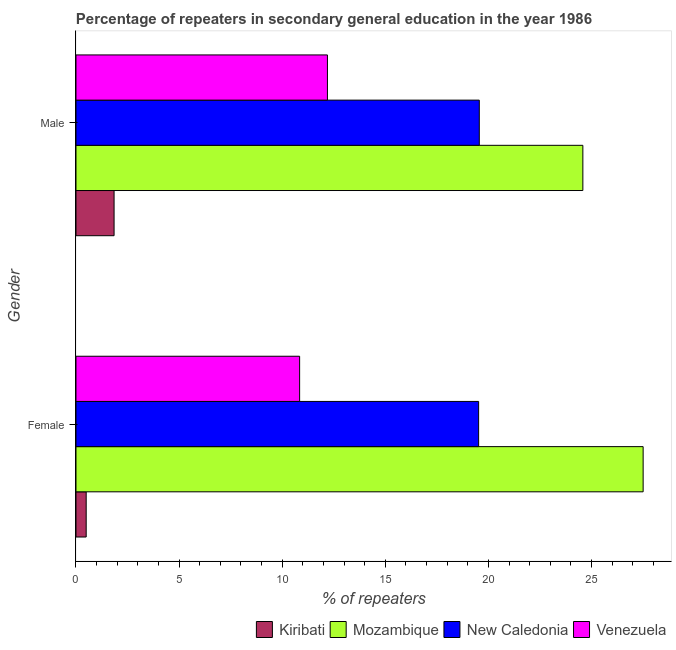How many different coloured bars are there?
Your answer should be compact. 4. Are the number of bars on each tick of the Y-axis equal?
Ensure brevity in your answer.  Yes. How many bars are there on the 1st tick from the top?
Keep it short and to the point. 4. What is the label of the 2nd group of bars from the top?
Your response must be concise. Female. What is the percentage of female repeaters in Kiribati?
Your response must be concise. 0.49. Across all countries, what is the maximum percentage of female repeaters?
Make the answer very short. 27.5. Across all countries, what is the minimum percentage of male repeaters?
Your response must be concise. 1.85. In which country was the percentage of female repeaters maximum?
Keep it short and to the point. Mozambique. In which country was the percentage of female repeaters minimum?
Ensure brevity in your answer.  Kiribati. What is the total percentage of female repeaters in the graph?
Keep it short and to the point. 58.37. What is the difference between the percentage of female repeaters in New Caledonia and that in Venezuela?
Offer a very short reply. 8.68. What is the difference between the percentage of male repeaters in Kiribati and the percentage of female repeaters in Mozambique?
Your answer should be compact. -25.66. What is the average percentage of male repeaters per country?
Your response must be concise. 14.54. What is the difference between the percentage of male repeaters and percentage of female repeaters in New Caledonia?
Give a very brief answer. 0.03. What is the ratio of the percentage of female repeaters in Venezuela to that in New Caledonia?
Provide a short and direct response. 0.56. Is the percentage of male repeaters in New Caledonia less than that in Mozambique?
Offer a terse response. Yes. What does the 4th bar from the top in Male represents?
Make the answer very short. Kiribati. What does the 2nd bar from the bottom in Male represents?
Your answer should be very brief. Mozambique. What is the difference between two consecutive major ticks on the X-axis?
Offer a terse response. 5. Where does the legend appear in the graph?
Ensure brevity in your answer.  Bottom right. How are the legend labels stacked?
Ensure brevity in your answer.  Horizontal. What is the title of the graph?
Offer a very short reply. Percentage of repeaters in secondary general education in the year 1986. What is the label or title of the X-axis?
Provide a succinct answer. % of repeaters. What is the % of repeaters of Kiribati in Female?
Your answer should be very brief. 0.49. What is the % of repeaters in Mozambique in Female?
Provide a succinct answer. 27.5. What is the % of repeaters in New Caledonia in Female?
Make the answer very short. 19.52. What is the % of repeaters in Venezuela in Female?
Provide a succinct answer. 10.84. What is the % of repeaters of Kiribati in Male?
Offer a very short reply. 1.85. What is the % of repeaters of Mozambique in Male?
Offer a very short reply. 24.58. What is the % of repeaters of New Caledonia in Male?
Keep it short and to the point. 19.56. What is the % of repeaters of Venezuela in Male?
Provide a short and direct response. 12.19. Across all Gender, what is the maximum % of repeaters of Kiribati?
Provide a succinct answer. 1.85. Across all Gender, what is the maximum % of repeaters of Mozambique?
Offer a very short reply. 27.5. Across all Gender, what is the maximum % of repeaters in New Caledonia?
Provide a succinct answer. 19.56. Across all Gender, what is the maximum % of repeaters of Venezuela?
Give a very brief answer. 12.19. Across all Gender, what is the minimum % of repeaters in Kiribati?
Your answer should be compact. 0.49. Across all Gender, what is the minimum % of repeaters in Mozambique?
Provide a short and direct response. 24.58. Across all Gender, what is the minimum % of repeaters in New Caledonia?
Your answer should be compact. 19.52. Across all Gender, what is the minimum % of repeaters of Venezuela?
Keep it short and to the point. 10.84. What is the total % of repeaters of Kiribati in the graph?
Make the answer very short. 2.34. What is the total % of repeaters in Mozambique in the graph?
Your answer should be compact. 52.08. What is the total % of repeaters in New Caledonia in the graph?
Keep it short and to the point. 39.08. What is the total % of repeaters in Venezuela in the graph?
Your answer should be very brief. 23.04. What is the difference between the % of repeaters in Kiribati in Female and that in Male?
Offer a terse response. -1.35. What is the difference between the % of repeaters in Mozambique in Female and that in Male?
Your response must be concise. 2.92. What is the difference between the % of repeaters of New Caledonia in Female and that in Male?
Ensure brevity in your answer.  -0.03. What is the difference between the % of repeaters of Venezuela in Female and that in Male?
Offer a terse response. -1.35. What is the difference between the % of repeaters of Kiribati in Female and the % of repeaters of Mozambique in Male?
Give a very brief answer. -24.09. What is the difference between the % of repeaters of Kiribati in Female and the % of repeaters of New Caledonia in Male?
Provide a succinct answer. -19.06. What is the difference between the % of repeaters of Kiribati in Female and the % of repeaters of Venezuela in Male?
Provide a short and direct response. -11.7. What is the difference between the % of repeaters of Mozambique in Female and the % of repeaters of New Caledonia in Male?
Offer a terse response. 7.94. What is the difference between the % of repeaters in Mozambique in Female and the % of repeaters in Venezuela in Male?
Make the answer very short. 15.31. What is the difference between the % of repeaters of New Caledonia in Female and the % of repeaters of Venezuela in Male?
Your answer should be compact. 7.33. What is the average % of repeaters in Kiribati per Gender?
Keep it short and to the point. 1.17. What is the average % of repeaters in Mozambique per Gender?
Make the answer very short. 26.04. What is the average % of repeaters in New Caledonia per Gender?
Ensure brevity in your answer.  19.54. What is the average % of repeaters of Venezuela per Gender?
Provide a succinct answer. 11.52. What is the difference between the % of repeaters of Kiribati and % of repeaters of Mozambique in Female?
Make the answer very short. -27.01. What is the difference between the % of repeaters of Kiribati and % of repeaters of New Caledonia in Female?
Offer a terse response. -19.03. What is the difference between the % of repeaters of Kiribati and % of repeaters of Venezuela in Female?
Ensure brevity in your answer.  -10.35. What is the difference between the % of repeaters of Mozambique and % of repeaters of New Caledonia in Female?
Provide a succinct answer. 7.98. What is the difference between the % of repeaters of Mozambique and % of repeaters of Venezuela in Female?
Your answer should be compact. 16.66. What is the difference between the % of repeaters in New Caledonia and % of repeaters in Venezuela in Female?
Your answer should be compact. 8.68. What is the difference between the % of repeaters of Kiribati and % of repeaters of Mozambique in Male?
Your answer should be compact. -22.73. What is the difference between the % of repeaters in Kiribati and % of repeaters in New Caledonia in Male?
Offer a terse response. -17.71. What is the difference between the % of repeaters in Kiribati and % of repeaters in Venezuela in Male?
Provide a succinct answer. -10.35. What is the difference between the % of repeaters in Mozambique and % of repeaters in New Caledonia in Male?
Provide a short and direct response. 5.02. What is the difference between the % of repeaters in Mozambique and % of repeaters in Venezuela in Male?
Your answer should be compact. 12.39. What is the difference between the % of repeaters of New Caledonia and % of repeaters of Venezuela in Male?
Ensure brevity in your answer.  7.36. What is the ratio of the % of repeaters of Kiribati in Female to that in Male?
Offer a very short reply. 0.27. What is the ratio of the % of repeaters in Mozambique in Female to that in Male?
Offer a terse response. 1.12. What is the ratio of the % of repeaters of Venezuela in Female to that in Male?
Ensure brevity in your answer.  0.89. What is the difference between the highest and the second highest % of repeaters of Kiribati?
Offer a terse response. 1.35. What is the difference between the highest and the second highest % of repeaters in Mozambique?
Give a very brief answer. 2.92. What is the difference between the highest and the second highest % of repeaters of New Caledonia?
Ensure brevity in your answer.  0.03. What is the difference between the highest and the second highest % of repeaters in Venezuela?
Your response must be concise. 1.35. What is the difference between the highest and the lowest % of repeaters in Kiribati?
Make the answer very short. 1.35. What is the difference between the highest and the lowest % of repeaters in Mozambique?
Keep it short and to the point. 2.92. What is the difference between the highest and the lowest % of repeaters of New Caledonia?
Offer a terse response. 0.03. What is the difference between the highest and the lowest % of repeaters of Venezuela?
Offer a very short reply. 1.35. 